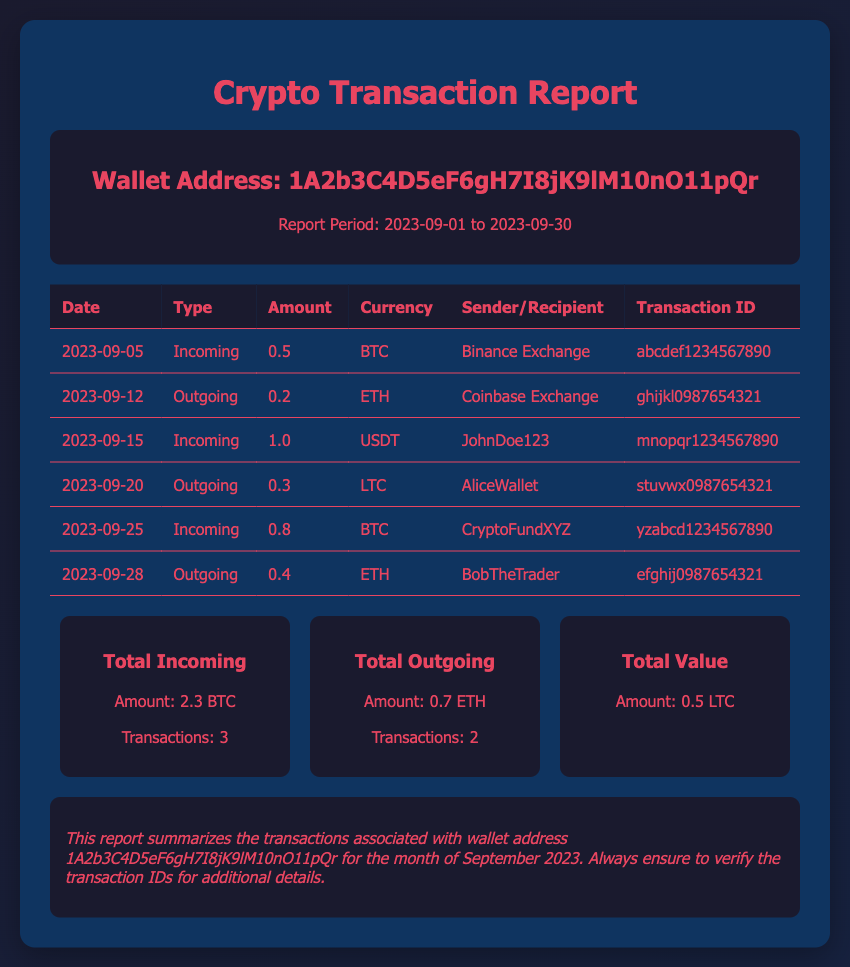What is the wallet address? The wallet address is specific to the report and is provided in the document's header section.
Answer: 1A2b3C4D5eF6gH7I8jK9lM10nO11pQr What is the total incoming amount? The total incoming amount can be calculated by summing all incoming transactions listed in the report.
Answer: 2.3 BTC How many outgoing transactions are reported? The number of outgoing transactions can be found by counting the entries labeled as outgoing in the transaction table.
Answer: 2 What type of currency was received on 2023-09-15? The transaction details for this date specify the type of currency received, which is listed under the "Currency" column.
Answer: USDT What is the transaction ID for the outgoing transaction on 2023-09-12? The transaction ID is provided next to each transaction entry, making it easy to retrieve.
Answer: ghijkl0987654321 Who was the recipient in the outgoing transaction on 2023-09-20? The recipient's information is listed in the transaction details under the "Sender/Recipient" column.
Answer: AliceWallet How many total transactions occurred during the month? The total number of transactions can be calculated by counting all entries in the transaction table.
Answer: 6 What is the date of the last incoming transaction? The last incoming transaction can be identified by checking the dates in the transactions table.
Answer: 2023-09-25 